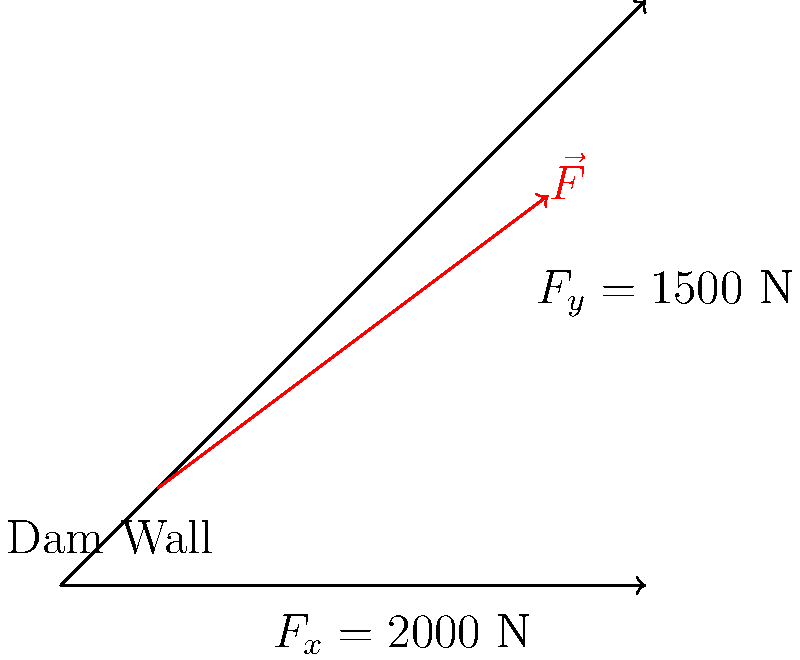As a concerned resident of western Sydney, you're monitoring the nearby dam during heavy rainfall. Engineers have determined that floodwaters are exerting a force on the dam wall with horizontal (x) and vertical (y) components of 2000 N and 1500 N respectively. What is the magnitude of the total force vector $\vec{F}$ acting on the dam wall? To find the magnitude of the total force vector $\vec{F}$, we need to use the Pythagorean theorem, as the x and y components form a right-angled triangle with the resultant force vector.

Step 1: Identify the components
$F_x = 2000$ N
$F_y = 1500$ N

Step 2: Apply the Pythagorean theorem
The magnitude of the force vector is given by:
$$|\vec{F}| = \sqrt{F_x^2 + F_y^2}$$

Step 3: Substitute the values
$$|\vec{F}| = \sqrt{(2000\text{ N})^2 + (1500\text{ N})^2}$$

Step 4: Calculate
$$|\vec{F}| = \sqrt{4,000,000\text{ N}^2 + 2,250,000\text{ N}^2}$$
$$|\vec{F}| = \sqrt{6,250,000\text{ N}^2}$$
$$|\vec{F}| = 2500\text{ N}$$

Therefore, the magnitude of the total force vector acting on the dam wall is 2500 N.
Answer: 2500 N 